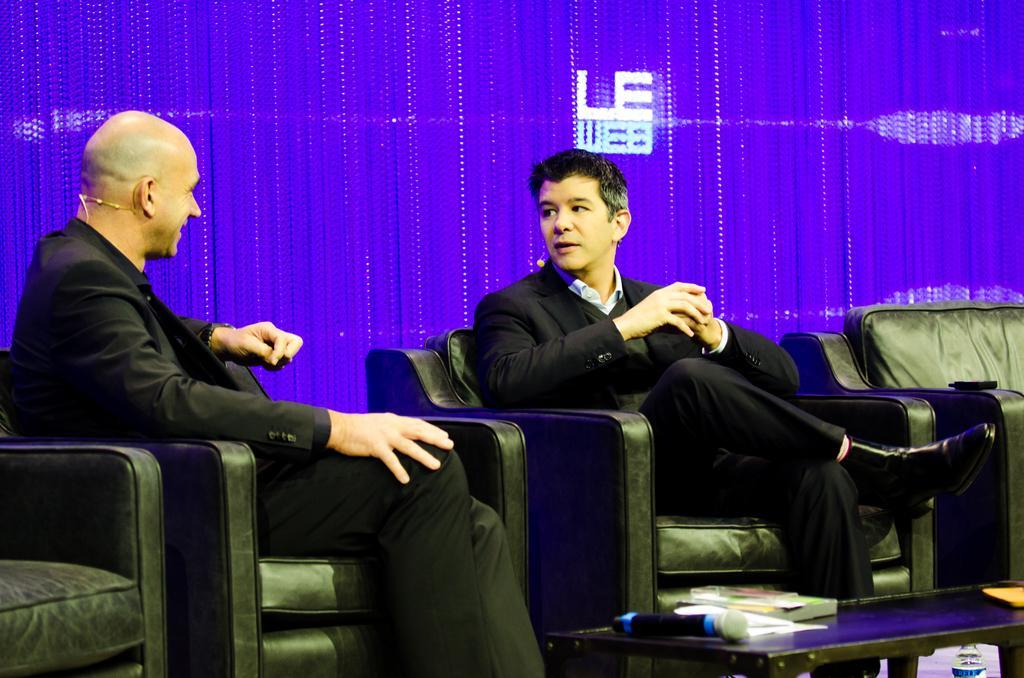In one or two sentences, can you explain what this image depicts? In this image I can see two men are sitting. Here on this table I can see a mic and under it I can see a bottle. 